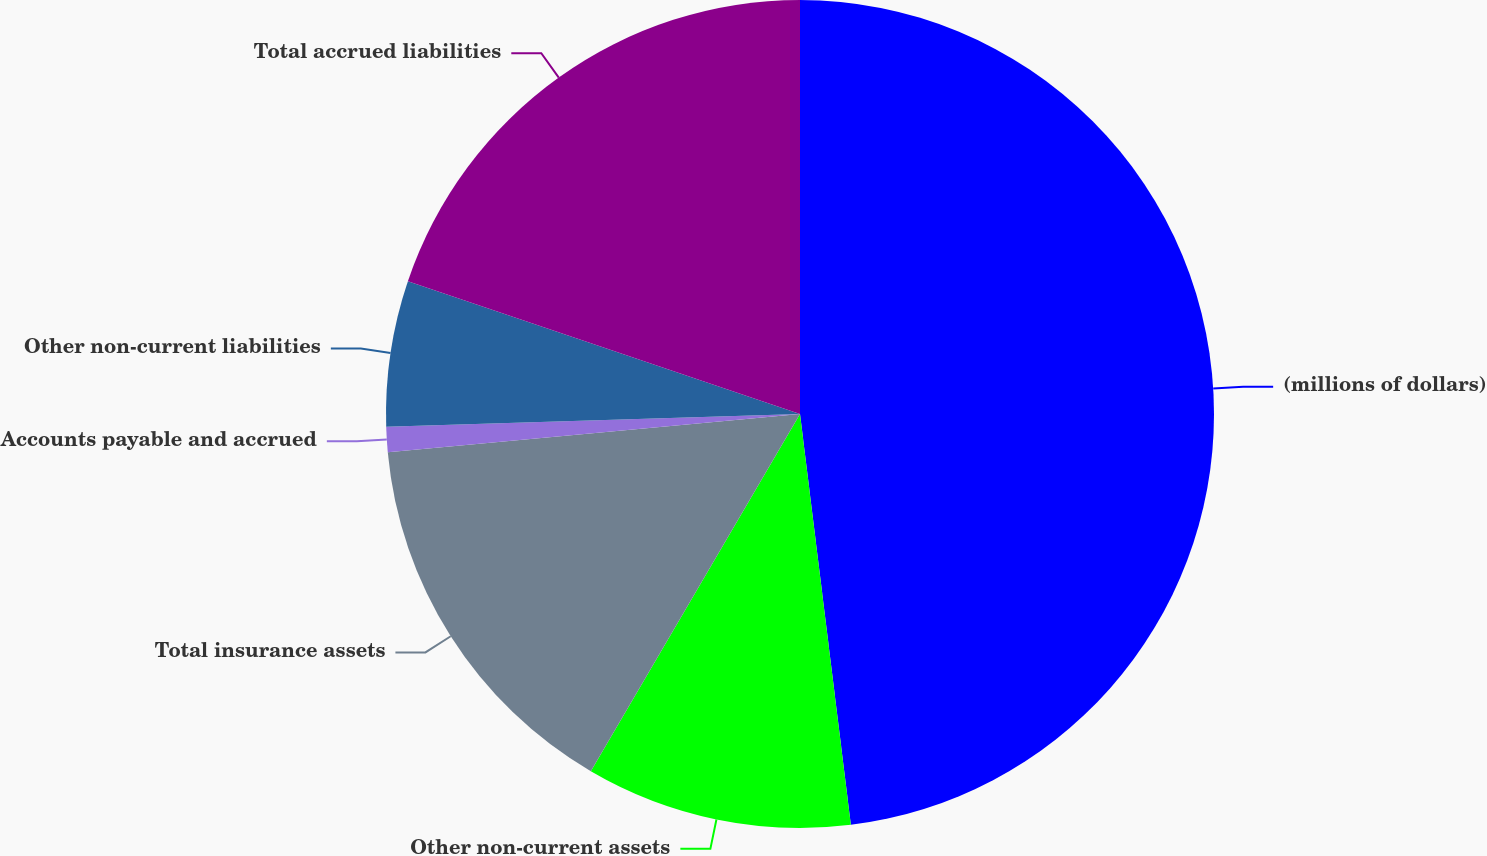<chart> <loc_0><loc_0><loc_500><loc_500><pie_chart><fcel>(millions of dollars)<fcel>Other non-current assets<fcel>Total insurance assets<fcel>Accounts payable and accrued<fcel>Other non-current liabilities<fcel>Total accrued liabilities<nl><fcel>48.04%<fcel>10.39%<fcel>15.1%<fcel>0.98%<fcel>5.69%<fcel>19.8%<nl></chart> 